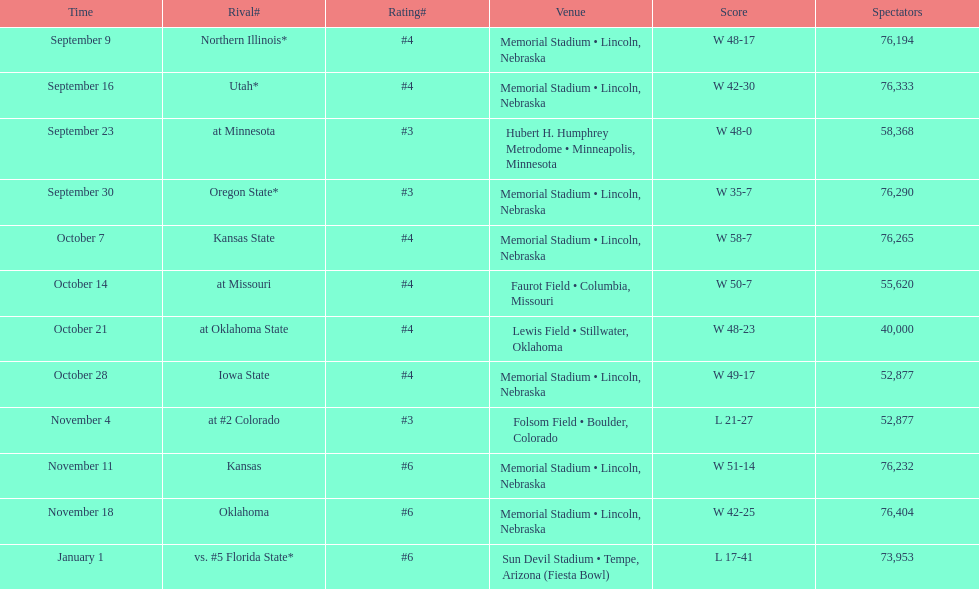Typically, how many instances was "w" recorded as the result? 10. 